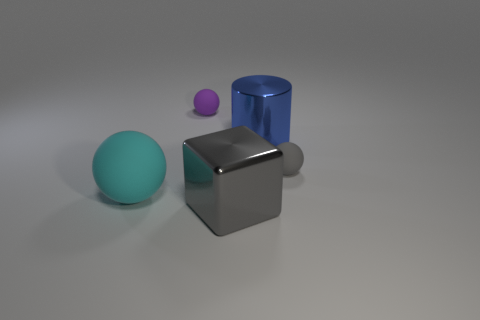Subtract all tiny rubber balls. How many balls are left? 1 Add 1 green blocks. How many objects exist? 6 Subtract all cyan balls. How many balls are left? 2 Subtract 1 cylinders. How many cylinders are left? 0 Subtract all cylinders. How many objects are left? 4 Subtract all cyan spheres. How many purple cylinders are left? 0 Add 1 small gray spheres. How many small gray spheres are left? 2 Add 1 blue cylinders. How many blue cylinders exist? 2 Subtract 0 gray cylinders. How many objects are left? 5 Subtract all green balls. Subtract all red cubes. How many balls are left? 3 